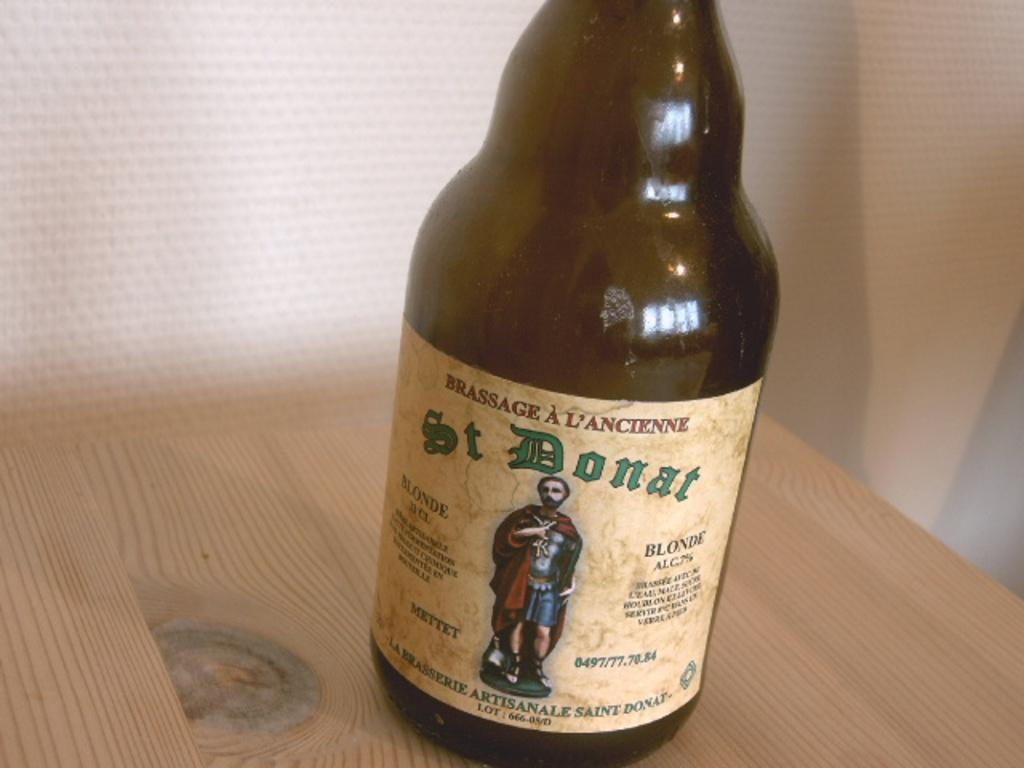Provide a one-sentence caption for the provided image. A bottle of St Donat lager sits on a wooden table. 